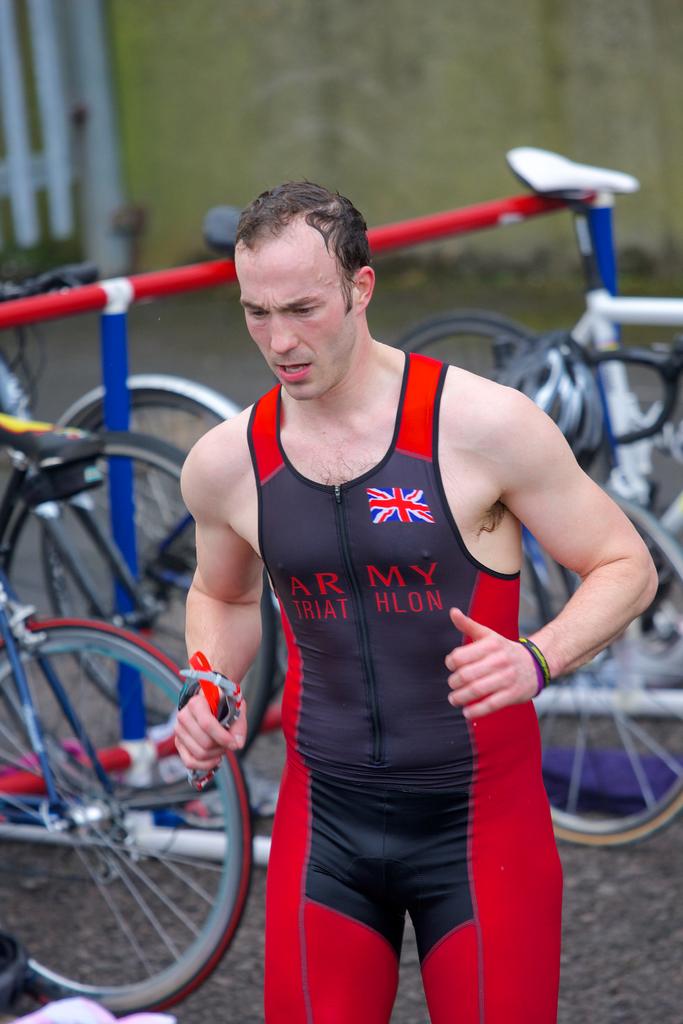What military branch is cited on the outfit?
Offer a very short reply. Army. What does the man's shirt say?
Keep it short and to the point. Army triathlon. 